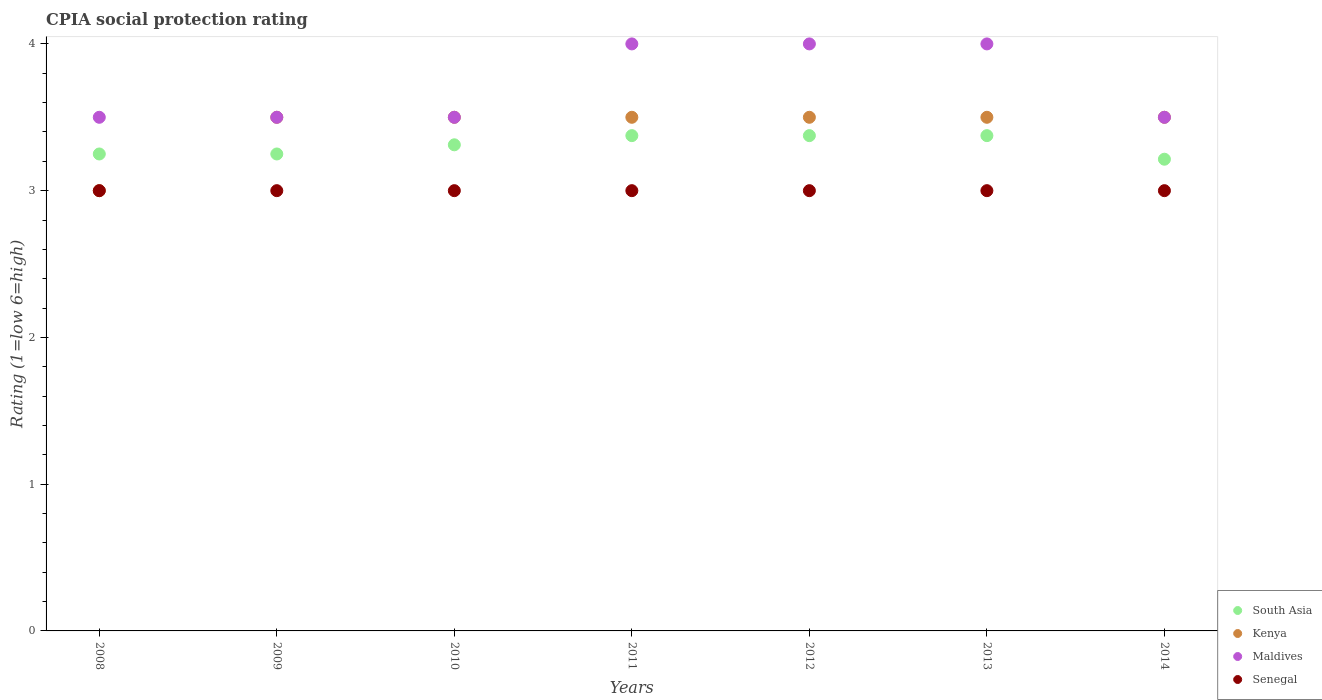How many different coloured dotlines are there?
Make the answer very short. 4. What is the CPIA rating in Maldives in 2013?
Give a very brief answer. 4. Across all years, what is the maximum CPIA rating in South Asia?
Provide a short and direct response. 3.38. In which year was the CPIA rating in Kenya maximum?
Give a very brief answer. 2009. What is the difference between the CPIA rating in Maldives in 2010 and that in 2012?
Your answer should be compact. -0.5. What is the difference between the CPIA rating in Senegal in 2009 and the CPIA rating in Maldives in 2010?
Ensure brevity in your answer.  -0.5. What is the average CPIA rating in South Asia per year?
Your response must be concise. 3.31. In the year 2013, what is the difference between the CPIA rating in Senegal and CPIA rating in South Asia?
Offer a very short reply. -0.38. In how many years, is the CPIA rating in South Asia greater than 2.4?
Give a very brief answer. 7. What is the difference between the highest and the second highest CPIA rating in Kenya?
Your response must be concise. 0. What is the difference between the highest and the lowest CPIA rating in Kenya?
Keep it short and to the point. 0.5. Is it the case that in every year, the sum of the CPIA rating in Kenya and CPIA rating in Senegal  is greater than the sum of CPIA rating in South Asia and CPIA rating in Maldives?
Your answer should be compact. No. Is it the case that in every year, the sum of the CPIA rating in Senegal and CPIA rating in Kenya  is greater than the CPIA rating in Maldives?
Your answer should be compact. Yes. Does the CPIA rating in Maldives monotonically increase over the years?
Your answer should be compact. No. Is the CPIA rating in Senegal strictly greater than the CPIA rating in South Asia over the years?
Your response must be concise. No. How many years are there in the graph?
Keep it short and to the point. 7. Are the values on the major ticks of Y-axis written in scientific E-notation?
Offer a terse response. No. Does the graph contain grids?
Keep it short and to the point. No. How many legend labels are there?
Ensure brevity in your answer.  4. How are the legend labels stacked?
Ensure brevity in your answer.  Vertical. What is the title of the graph?
Your answer should be compact. CPIA social protection rating. What is the label or title of the X-axis?
Your response must be concise. Years. What is the label or title of the Y-axis?
Your answer should be very brief. Rating (1=low 6=high). What is the Rating (1=low 6=high) in South Asia in 2008?
Ensure brevity in your answer.  3.25. What is the Rating (1=low 6=high) of Maldives in 2008?
Keep it short and to the point. 3.5. What is the Rating (1=low 6=high) of South Asia in 2009?
Offer a very short reply. 3.25. What is the Rating (1=low 6=high) of Maldives in 2009?
Offer a very short reply. 3.5. What is the Rating (1=low 6=high) in Senegal in 2009?
Your answer should be compact. 3. What is the Rating (1=low 6=high) of South Asia in 2010?
Give a very brief answer. 3.31. What is the Rating (1=low 6=high) of Kenya in 2010?
Your answer should be compact. 3.5. What is the Rating (1=low 6=high) in South Asia in 2011?
Offer a terse response. 3.38. What is the Rating (1=low 6=high) in Kenya in 2011?
Your response must be concise. 3.5. What is the Rating (1=low 6=high) in South Asia in 2012?
Make the answer very short. 3.38. What is the Rating (1=low 6=high) of Kenya in 2012?
Offer a terse response. 3.5. What is the Rating (1=low 6=high) of Maldives in 2012?
Offer a very short reply. 4. What is the Rating (1=low 6=high) in Senegal in 2012?
Give a very brief answer. 3. What is the Rating (1=low 6=high) in South Asia in 2013?
Provide a short and direct response. 3.38. What is the Rating (1=low 6=high) in Maldives in 2013?
Your response must be concise. 4. What is the Rating (1=low 6=high) of South Asia in 2014?
Your response must be concise. 3.21. What is the Rating (1=low 6=high) of Senegal in 2014?
Your answer should be very brief. 3. Across all years, what is the maximum Rating (1=low 6=high) of South Asia?
Your response must be concise. 3.38. Across all years, what is the minimum Rating (1=low 6=high) of South Asia?
Make the answer very short. 3.21. Across all years, what is the minimum Rating (1=low 6=high) in Senegal?
Your response must be concise. 3. What is the total Rating (1=low 6=high) in South Asia in the graph?
Provide a short and direct response. 23.15. What is the total Rating (1=low 6=high) in Kenya in the graph?
Give a very brief answer. 24. What is the total Rating (1=low 6=high) of Maldives in the graph?
Your response must be concise. 26. What is the difference between the Rating (1=low 6=high) of South Asia in 2008 and that in 2009?
Offer a terse response. 0. What is the difference between the Rating (1=low 6=high) of Kenya in 2008 and that in 2009?
Give a very brief answer. -0.5. What is the difference between the Rating (1=low 6=high) of Maldives in 2008 and that in 2009?
Your answer should be very brief. 0. What is the difference between the Rating (1=low 6=high) of South Asia in 2008 and that in 2010?
Your response must be concise. -0.06. What is the difference between the Rating (1=low 6=high) of Maldives in 2008 and that in 2010?
Offer a very short reply. 0. What is the difference between the Rating (1=low 6=high) of South Asia in 2008 and that in 2011?
Provide a succinct answer. -0.12. What is the difference between the Rating (1=low 6=high) in Kenya in 2008 and that in 2011?
Ensure brevity in your answer.  -0.5. What is the difference between the Rating (1=low 6=high) in Maldives in 2008 and that in 2011?
Your answer should be very brief. -0.5. What is the difference between the Rating (1=low 6=high) in Senegal in 2008 and that in 2011?
Ensure brevity in your answer.  0. What is the difference between the Rating (1=low 6=high) of South Asia in 2008 and that in 2012?
Your answer should be very brief. -0.12. What is the difference between the Rating (1=low 6=high) of South Asia in 2008 and that in 2013?
Keep it short and to the point. -0.12. What is the difference between the Rating (1=low 6=high) in Maldives in 2008 and that in 2013?
Your answer should be compact. -0.5. What is the difference between the Rating (1=low 6=high) in Senegal in 2008 and that in 2013?
Give a very brief answer. 0. What is the difference between the Rating (1=low 6=high) of South Asia in 2008 and that in 2014?
Make the answer very short. 0.04. What is the difference between the Rating (1=low 6=high) of Kenya in 2008 and that in 2014?
Your response must be concise. -0.5. What is the difference between the Rating (1=low 6=high) of Senegal in 2008 and that in 2014?
Your answer should be very brief. 0. What is the difference between the Rating (1=low 6=high) of South Asia in 2009 and that in 2010?
Your response must be concise. -0.06. What is the difference between the Rating (1=low 6=high) in Maldives in 2009 and that in 2010?
Offer a terse response. 0. What is the difference between the Rating (1=low 6=high) of South Asia in 2009 and that in 2011?
Ensure brevity in your answer.  -0.12. What is the difference between the Rating (1=low 6=high) of Senegal in 2009 and that in 2011?
Your answer should be very brief. 0. What is the difference between the Rating (1=low 6=high) of South Asia in 2009 and that in 2012?
Offer a terse response. -0.12. What is the difference between the Rating (1=low 6=high) in Kenya in 2009 and that in 2012?
Ensure brevity in your answer.  0. What is the difference between the Rating (1=low 6=high) in Senegal in 2009 and that in 2012?
Your answer should be very brief. 0. What is the difference between the Rating (1=low 6=high) in South Asia in 2009 and that in 2013?
Your response must be concise. -0.12. What is the difference between the Rating (1=low 6=high) in Kenya in 2009 and that in 2013?
Offer a very short reply. 0. What is the difference between the Rating (1=low 6=high) in Senegal in 2009 and that in 2013?
Your response must be concise. 0. What is the difference between the Rating (1=low 6=high) in South Asia in 2009 and that in 2014?
Make the answer very short. 0.04. What is the difference between the Rating (1=low 6=high) of Kenya in 2009 and that in 2014?
Your answer should be compact. 0. What is the difference between the Rating (1=low 6=high) of Maldives in 2009 and that in 2014?
Provide a short and direct response. 0. What is the difference between the Rating (1=low 6=high) in South Asia in 2010 and that in 2011?
Provide a succinct answer. -0.06. What is the difference between the Rating (1=low 6=high) of Maldives in 2010 and that in 2011?
Provide a succinct answer. -0.5. What is the difference between the Rating (1=low 6=high) in Senegal in 2010 and that in 2011?
Your answer should be very brief. 0. What is the difference between the Rating (1=low 6=high) in South Asia in 2010 and that in 2012?
Offer a terse response. -0.06. What is the difference between the Rating (1=low 6=high) of Senegal in 2010 and that in 2012?
Offer a very short reply. 0. What is the difference between the Rating (1=low 6=high) of South Asia in 2010 and that in 2013?
Your answer should be compact. -0.06. What is the difference between the Rating (1=low 6=high) of Senegal in 2010 and that in 2013?
Your answer should be compact. 0. What is the difference between the Rating (1=low 6=high) of South Asia in 2010 and that in 2014?
Give a very brief answer. 0.1. What is the difference between the Rating (1=low 6=high) in Maldives in 2011 and that in 2012?
Provide a short and direct response. 0. What is the difference between the Rating (1=low 6=high) of Senegal in 2011 and that in 2012?
Provide a short and direct response. 0. What is the difference between the Rating (1=low 6=high) in Maldives in 2011 and that in 2013?
Give a very brief answer. 0. What is the difference between the Rating (1=low 6=high) of South Asia in 2011 and that in 2014?
Give a very brief answer. 0.16. What is the difference between the Rating (1=low 6=high) in Maldives in 2011 and that in 2014?
Give a very brief answer. 0.5. What is the difference between the Rating (1=low 6=high) of Senegal in 2011 and that in 2014?
Give a very brief answer. 0. What is the difference between the Rating (1=low 6=high) in Kenya in 2012 and that in 2013?
Your response must be concise. 0. What is the difference between the Rating (1=low 6=high) of Maldives in 2012 and that in 2013?
Your answer should be very brief. 0. What is the difference between the Rating (1=low 6=high) of Senegal in 2012 and that in 2013?
Offer a very short reply. 0. What is the difference between the Rating (1=low 6=high) in South Asia in 2012 and that in 2014?
Provide a short and direct response. 0.16. What is the difference between the Rating (1=low 6=high) of Kenya in 2012 and that in 2014?
Give a very brief answer. 0. What is the difference between the Rating (1=low 6=high) of Senegal in 2012 and that in 2014?
Your answer should be compact. 0. What is the difference between the Rating (1=low 6=high) in South Asia in 2013 and that in 2014?
Your response must be concise. 0.16. What is the difference between the Rating (1=low 6=high) in Kenya in 2013 and that in 2014?
Ensure brevity in your answer.  0. What is the difference between the Rating (1=low 6=high) of Maldives in 2013 and that in 2014?
Offer a terse response. 0.5. What is the difference between the Rating (1=low 6=high) in Kenya in 2008 and the Rating (1=low 6=high) in Maldives in 2009?
Keep it short and to the point. -0.5. What is the difference between the Rating (1=low 6=high) of Kenya in 2008 and the Rating (1=low 6=high) of Senegal in 2009?
Make the answer very short. 0. What is the difference between the Rating (1=low 6=high) in South Asia in 2008 and the Rating (1=low 6=high) in Kenya in 2010?
Your answer should be compact. -0.25. What is the difference between the Rating (1=low 6=high) in South Asia in 2008 and the Rating (1=low 6=high) in Senegal in 2010?
Offer a very short reply. 0.25. What is the difference between the Rating (1=low 6=high) of South Asia in 2008 and the Rating (1=low 6=high) of Kenya in 2011?
Your answer should be very brief. -0.25. What is the difference between the Rating (1=low 6=high) in South Asia in 2008 and the Rating (1=low 6=high) in Maldives in 2011?
Your answer should be compact. -0.75. What is the difference between the Rating (1=low 6=high) of Kenya in 2008 and the Rating (1=low 6=high) of Maldives in 2011?
Your response must be concise. -1. What is the difference between the Rating (1=low 6=high) in Maldives in 2008 and the Rating (1=low 6=high) in Senegal in 2011?
Your answer should be compact. 0.5. What is the difference between the Rating (1=low 6=high) of South Asia in 2008 and the Rating (1=low 6=high) of Kenya in 2012?
Provide a succinct answer. -0.25. What is the difference between the Rating (1=low 6=high) of South Asia in 2008 and the Rating (1=low 6=high) of Maldives in 2012?
Offer a terse response. -0.75. What is the difference between the Rating (1=low 6=high) in Maldives in 2008 and the Rating (1=low 6=high) in Senegal in 2012?
Provide a short and direct response. 0.5. What is the difference between the Rating (1=low 6=high) of South Asia in 2008 and the Rating (1=low 6=high) of Kenya in 2013?
Your answer should be very brief. -0.25. What is the difference between the Rating (1=low 6=high) in South Asia in 2008 and the Rating (1=low 6=high) in Maldives in 2013?
Ensure brevity in your answer.  -0.75. What is the difference between the Rating (1=low 6=high) of South Asia in 2008 and the Rating (1=low 6=high) of Senegal in 2013?
Make the answer very short. 0.25. What is the difference between the Rating (1=low 6=high) in Kenya in 2008 and the Rating (1=low 6=high) in Senegal in 2013?
Your answer should be compact. 0. What is the difference between the Rating (1=low 6=high) of Kenya in 2008 and the Rating (1=low 6=high) of Maldives in 2014?
Your response must be concise. -0.5. What is the difference between the Rating (1=low 6=high) in Maldives in 2008 and the Rating (1=low 6=high) in Senegal in 2014?
Ensure brevity in your answer.  0.5. What is the difference between the Rating (1=low 6=high) of Kenya in 2009 and the Rating (1=low 6=high) of Maldives in 2010?
Offer a terse response. 0. What is the difference between the Rating (1=low 6=high) of Kenya in 2009 and the Rating (1=low 6=high) of Senegal in 2010?
Give a very brief answer. 0.5. What is the difference between the Rating (1=low 6=high) in Maldives in 2009 and the Rating (1=low 6=high) in Senegal in 2010?
Give a very brief answer. 0.5. What is the difference between the Rating (1=low 6=high) in South Asia in 2009 and the Rating (1=low 6=high) in Kenya in 2011?
Your response must be concise. -0.25. What is the difference between the Rating (1=low 6=high) of South Asia in 2009 and the Rating (1=low 6=high) of Maldives in 2011?
Ensure brevity in your answer.  -0.75. What is the difference between the Rating (1=low 6=high) of South Asia in 2009 and the Rating (1=low 6=high) of Senegal in 2011?
Your answer should be compact. 0.25. What is the difference between the Rating (1=low 6=high) of Kenya in 2009 and the Rating (1=low 6=high) of Maldives in 2011?
Provide a succinct answer. -0.5. What is the difference between the Rating (1=low 6=high) of Maldives in 2009 and the Rating (1=low 6=high) of Senegal in 2011?
Ensure brevity in your answer.  0.5. What is the difference between the Rating (1=low 6=high) of South Asia in 2009 and the Rating (1=low 6=high) of Kenya in 2012?
Keep it short and to the point. -0.25. What is the difference between the Rating (1=low 6=high) in South Asia in 2009 and the Rating (1=low 6=high) in Maldives in 2012?
Provide a short and direct response. -0.75. What is the difference between the Rating (1=low 6=high) of Kenya in 2009 and the Rating (1=low 6=high) of Maldives in 2012?
Offer a very short reply. -0.5. What is the difference between the Rating (1=low 6=high) of Kenya in 2009 and the Rating (1=low 6=high) of Senegal in 2012?
Ensure brevity in your answer.  0.5. What is the difference between the Rating (1=low 6=high) of South Asia in 2009 and the Rating (1=low 6=high) of Maldives in 2013?
Make the answer very short. -0.75. What is the difference between the Rating (1=low 6=high) in South Asia in 2009 and the Rating (1=low 6=high) in Senegal in 2013?
Keep it short and to the point. 0.25. What is the difference between the Rating (1=low 6=high) in Kenya in 2009 and the Rating (1=low 6=high) in Maldives in 2013?
Provide a succinct answer. -0.5. What is the difference between the Rating (1=low 6=high) of South Asia in 2009 and the Rating (1=low 6=high) of Maldives in 2014?
Offer a terse response. -0.25. What is the difference between the Rating (1=low 6=high) in South Asia in 2009 and the Rating (1=low 6=high) in Senegal in 2014?
Give a very brief answer. 0.25. What is the difference between the Rating (1=low 6=high) in Kenya in 2009 and the Rating (1=low 6=high) in Maldives in 2014?
Give a very brief answer. 0. What is the difference between the Rating (1=low 6=high) in Kenya in 2009 and the Rating (1=low 6=high) in Senegal in 2014?
Ensure brevity in your answer.  0.5. What is the difference between the Rating (1=low 6=high) in South Asia in 2010 and the Rating (1=low 6=high) in Kenya in 2011?
Give a very brief answer. -0.19. What is the difference between the Rating (1=low 6=high) in South Asia in 2010 and the Rating (1=low 6=high) in Maldives in 2011?
Make the answer very short. -0.69. What is the difference between the Rating (1=low 6=high) of South Asia in 2010 and the Rating (1=low 6=high) of Senegal in 2011?
Give a very brief answer. 0.31. What is the difference between the Rating (1=low 6=high) of South Asia in 2010 and the Rating (1=low 6=high) of Kenya in 2012?
Make the answer very short. -0.19. What is the difference between the Rating (1=low 6=high) in South Asia in 2010 and the Rating (1=low 6=high) in Maldives in 2012?
Ensure brevity in your answer.  -0.69. What is the difference between the Rating (1=low 6=high) of South Asia in 2010 and the Rating (1=low 6=high) of Senegal in 2012?
Make the answer very short. 0.31. What is the difference between the Rating (1=low 6=high) in South Asia in 2010 and the Rating (1=low 6=high) in Kenya in 2013?
Make the answer very short. -0.19. What is the difference between the Rating (1=low 6=high) in South Asia in 2010 and the Rating (1=low 6=high) in Maldives in 2013?
Make the answer very short. -0.69. What is the difference between the Rating (1=low 6=high) of South Asia in 2010 and the Rating (1=low 6=high) of Senegal in 2013?
Provide a succinct answer. 0.31. What is the difference between the Rating (1=low 6=high) of Kenya in 2010 and the Rating (1=low 6=high) of Maldives in 2013?
Provide a short and direct response. -0.5. What is the difference between the Rating (1=low 6=high) in South Asia in 2010 and the Rating (1=low 6=high) in Kenya in 2014?
Provide a succinct answer. -0.19. What is the difference between the Rating (1=low 6=high) in South Asia in 2010 and the Rating (1=low 6=high) in Maldives in 2014?
Your response must be concise. -0.19. What is the difference between the Rating (1=low 6=high) of South Asia in 2010 and the Rating (1=low 6=high) of Senegal in 2014?
Make the answer very short. 0.31. What is the difference between the Rating (1=low 6=high) in Kenya in 2010 and the Rating (1=low 6=high) in Senegal in 2014?
Provide a short and direct response. 0.5. What is the difference between the Rating (1=low 6=high) of South Asia in 2011 and the Rating (1=low 6=high) of Kenya in 2012?
Keep it short and to the point. -0.12. What is the difference between the Rating (1=low 6=high) of South Asia in 2011 and the Rating (1=low 6=high) of Maldives in 2012?
Keep it short and to the point. -0.62. What is the difference between the Rating (1=low 6=high) of Kenya in 2011 and the Rating (1=low 6=high) of Maldives in 2012?
Keep it short and to the point. -0.5. What is the difference between the Rating (1=low 6=high) in Kenya in 2011 and the Rating (1=low 6=high) in Senegal in 2012?
Provide a succinct answer. 0.5. What is the difference between the Rating (1=low 6=high) in Maldives in 2011 and the Rating (1=low 6=high) in Senegal in 2012?
Make the answer very short. 1. What is the difference between the Rating (1=low 6=high) of South Asia in 2011 and the Rating (1=low 6=high) of Kenya in 2013?
Ensure brevity in your answer.  -0.12. What is the difference between the Rating (1=low 6=high) of South Asia in 2011 and the Rating (1=low 6=high) of Maldives in 2013?
Offer a terse response. -0.62. What is the difference between the Rating (1=low 6=high) in South Asia in 2011 and the Rating (1=low 6=high) in Senegal in 2013?
Your response must be concise. 0.38. What is the difference between the Rating (1=low 6=high) of Kenya in 2011 and the Rating (1=low 6=high) of Maldives in 2013?
Offer a terse response. -0.5. What is the difference between the Rating (1=low 6=high) of Maldives in 2011 and the Rating (1=low 6=high) of Senegal in 2013?
Make the answer very short. 1. What is the difference between the Rating (1=low 6=high) of South Asia in 2011 and the Rating (1=low 6=high) of Kenya in 2014?
Keep it short and to the point. -0.12. What is the difference between the Rating (1=low 6=high) of South Asia in 2011 and the Rating (1=low 6=high) of Maldives in 2014?
Ensure brevity in your answer.  -0.12. What is the difference between the Rating (1=low 6=high) of South Asia in 2012 and the Rating (1=low 6=high) of Kenya in 2013?
Offer a very short reply. -0.12. What is the difference between the Rating (1=low 6=high) in South Asia in 2012 and the Rating (1=low 6=high) in Maldives in 2013?
Ensure brevity in your answer.  -0.62. What is the difference between the Rating (1=low 6=high) of Kenya in 2012 and the Rating (1=low 6=high) of Maldives in 2013?
Provide a short and direct response. -0.5. What is the difference between the Rating (1=low 6=high) in South Asia in 2012 and the Rating (1=low 6=high) in Kenya in 2014?
Ensure brevity in your answer.  -0.12. What is the difference between the Rating (1=low 6=high) of South Asia in 2012 and the Rating (1=low 6=high) of Maldives in 2014?
Ensure brevity in your answer.  -0.12. What is the difference between the Rating (1=low 6=high) in South Asia in 2012 and the Rating (1=low 6=high) in Senegal in 2014?
Your answer should be very brief. 0.38. What is the difference between the Rating (1=low 6=high) in South Asia in 2013 and the Rating (1=low 6=high) in Kenya in 2014?
Your answer should be compact. -0.12. What is the difference between the Rating (1=low 6=high) of South Asia in 2013 and the Rating (1=low 6=high) of Maldives in 2014?
Your response must be concise. -0.12. What is the difference between the Rating (1=low 6=high) of South Asia in 2013 and the Rating (1=low 6=high) of Senegal in 2014?
Offer a very short reply. 0.38. What is the difference between the Rating (1=low 6=high) in Kenya in 2013 and the Rating (1=low 6=high) in Maldives in 2014?
Provide a short and direct response. 0. What is the average Rating (1=low 6=high) of South Asia per year?
Your response must be concise. 3.31. What is the average Rating (1=low 6=high) of Kenya per year?
Your answer should be very brief. 3.43. What is the average Rating (1=low 6=high) of Maldives per year?
Provide a short and direct response. 3.71. In the year 2008, what is the difference between the Rating (1=low 6=high) in South Asia and Rating (1=low 6=high) in Maldives?
Your answer should be compact. -0.25. In the year 2008, what is the difference between the Rating (1=low 6=high) of Kenya and Rating (1=low 6=high) of Maldives?
Provide a succinct answer. -0.5. In the year 2008, what is the difference between the Rating (1=low 6=high) in Maldives and Rating (1=low 6=high) in Senegal?
Ensure brevity in your answer.  0.5. In the year 2009, what is the difference between the Rating (1=low 6=high) of South Asia and Rating (1=low 6=high) of Kenya?
Your answer should be very brief. -0.25. In the year 2009, what is the difference between the Rating (1=low 6=high) in South Asia and Rating (1=low 6=high) in Senegal?
Offer a very short reply. 0.25. In the year 2009, what is the difference between the Rating (1=low 6=high) in Maldives and Rating (1=low 6=high) in Senegal?
Keep it short and to the point. 0.5. In the year 2010, what is the difference between the Rating (1=low 6=high) of South Asia and Rating (1=low 6=high) of Kenya?
Keep it short and to the point. -0.19. In the year 2010, what is the difference between the Rating (1=low 6=high) of South Asia and Rating (1=low 6=high) of Maldives?
Ensure brevity in your answer.  -0.19. In the year 2010, what is the difference between the Rating (1=low 6=high) of South Asia and Rating (1=low 6=high) of Senegal?
Your response must be concise. 0.31. In the year 2010, what is the difference between the Rating (1=low 6=high) in Kenya and Rating (1=low 6=high) in Maldives?
Your answer should be compact. 0. In the year 2010, what is the difference between the Rating (1=low 6=high) of Kenya and Rating (1=low 6=high) of Senegal?
Your response must be concise. 0.5. In the year 2010, what is the difference between the Rating (1=low 6=high) in Maldives and Rating (1=low 6=high) in Senegal?
Your answer should be compact. 0.5. In the year 2011, what is the difference between the Rating (1=low 6=high) of South Asia and Rating (1=low 6=high) of Kenya?
Provide a succinct answer. -0.12. In the year 2011, what is the difference between the Rating (1=low 6=high) of South Asia and Rating (1=low 6=high) of Maldives?
Offer a terse response. -0.62. In the year 2011, what is the difference between the Rating (1=low 6=high) of South Asia and Rating (1=low 6=high) of Senegal?
Your answer should be very brief. 0.38. In the year 2011, what is the difference between the Rating (1=low 6=high) of Kenya and Rating (1=low 6=high) of Senegal?
Ensure brevity in your answer.  0.5. In the year 2012, what is the difference between the Rating (1=low 6=high) of South Asia and Rating (1=low 6=high) of Kenya?
Give a very brief answer. -0.12. In the year 2012, what is the difference between the Rating (1=low 6=high) in South Asia and Rating (1=low 6=high) in Maldives?
Provide a short and direct response. -0.62. In the year 2012, what is the difference between the Rating (1=low 6=high) of Kenya and Rating (1=low 6=high) of Senegal?
Ensure brevity in your answer.  0.5. In the year 2013, what is the difference between the Rating (1=low 6=high) of South Asia and Rating (1=low 6=high) of Kenya?
Your answer should be compact. -0.12. In the year 2013, what is the difference between the Rating (1=low 6=high) in South Asia and Rating (1=low 6=high) in Maldives?
Your answer should be very brief. -0.62. In the year 2013, what is the difference between the Rating (1=low 6=high) in Kenya and Rating (1=low 6=high) in Senegal?
Make the answer very short. 0.5. In the year 2013, what is the difference between the Rating (1=low 6=high) of Maldives and Rating (1=low 6=high) of Senegal?
Provide a succinct answer. 1. In the year 2014, what is the difference between the Rating (1=low 6=high) of South Asia and Rating (1=low 6=high) of Kenya?
Ensure brevity in your answer.  -0.29. In the year 2014, what is the difference between the Rating (1=low 6=high) in South Asia and Rating (1=low 6=high) in Maldives?
Ensure brevity in your answer.  -0.29. In the year 2014, what is the difference between the Rating (1=low 6=high) of South Asia and Rating (1=low 6=high) of Senegal?
Provide a succinct answer. 0.21. In the year 2014, what is the difference between the Rating (1=low 6=high) in Kenya and Rating (1=low 6=high) in Maldives?
Give a very brief answer. 0. In the year 2014, what is the difference between the Rating (1=low 6=high) in Maldives and Rating (1=low 6=high) in Senegal?
Provide a short and direct response. 0.5. What is the ratio of the Rating (1=low 6=high) in South Asia in 2008 to that in 2009?
Your answer should be very brief. 1. What is the ratio of the Rating (1=low 6=high) of Kenya in 2008 to that in 2009?
Ensure brevity in your answer.  0.86. What is the ratio of the Rating (1=low 6=high) in South Asia in 2008 to that in 2010?
Offer a very short reply. 0.98. What is the ratio of the Rating (1=low 6=high) in Maldives in 2008 to that in 2010?
Give a very brief answer. 1. What is the ratio of the Rating (1=low 6=high) in Senegal in 2008 to that in 2010?
Provide a short and direct response. 1. What is the ratio of the Rating (1=low 6=high) of South Asia in 2008 to that in 2011?
Provide a succinct answer. 0.96. What is the ratio of the Rating (1=low 6=high) in Kenya in 2008 to that in 2011?
Your response must be concise. 0.86. What is the ratio of the Rating (1=low 6=high) in Maldives in 2008 to that in 2011?
Offer a very short reply. 0.88. What is the ratio of the Rating (1=low 6=high) of Senegal in 2008 to that in 2011?
Ensure brevity in your answer.  1. What is the ratio of the Rating (1=low 6=high) in Maldives in 2008 to that in 2012?
Your response must be concise. 0.88. What is the ratio of the Rating (1=low 6=high) in Senegal in 2008 to that in 2012?
Provide a succinct answer. 1. What is the ratio of the Rating (1=low 6=high) in Senegal in 2008 to that in 2013?
Make the answer very short. 1. What is the ratio of the Rating (1=low 6=high) in South Asia in 2008 to that in 2014?
Keep it short and to the point. 1.01. What is the ratio of the Rating (1=low 6=high) of Maldives in 2008 to that in 2014?
Ensure brevity in your answer.  1. What is the ratio of the Rating (1=low 6=high) in Senegal in 2008 to that in 2014?
Ensure brevity in your answer.  1. What is the ratio of the Rating (1=low 6=high) in South Asia in 2009 to that in 2010?
Provide a succinct answer. 0.98. What is the ratio of the Rating (1=low 6=high) in Senegal in 2009 to that in 2010?
Provide a short and direct response. 1. What is the ratio of the Rating (1=low 6=high) of South Asia in 2009 to that in 2011?
Your answer should be compact. 0.96. What is the ratio of the Rating (1=low 6=high) of Kenya in 2009 to that in 2011?
Your response must be concise. 1. What is the ratio of the Rating (1=low 6=high) of Maldives in 2009 to that in 2011?
Your response must be concise. 0.88. What is the ratio of the Rating (1=low 6=high) of Senegal in 2009 to that in 2011?
Provide a short and direct response. 1. What is the ratio of the Rating (1=low 6=high) in South Asia in 2009 to that in 2012?
Ensure brevity in your answer.  0.96. What is the ratio of the Rating (1=low 6=high) in Kenya in 2009 to that in 2012?
Offer a very short reply. 1. What is the ratio of the Rating (1=low 6=high) in Senegal in 2009 to that in 2012?
Provide a short and direct response. 1. What is the ratio of the Rating (1=low 6=high) in Kenya in 2009 to that in 2013?
Give a very brief answer. 1. What is the ratio of the Rating (1=low 6=high) in Senegal in 2009 to that in 2013?
Your response must be concise. 1. What is the ratio of the Rating (1=low 6=high) of South Asia in 2009 to that in 2014?
Provide a short and direct response. 1.01. What is the ratio of the Rating (1=low 6=high) of Maldives in 2009 to that in 2014?
Ensure brevity in your answer.  1. What is the ratio of the Rating (1=low 6=high) in Senegal in 2009 to that in 2014?
Ensure brevity in your answer.  1. What is the ratio of the Rating (1=low 6=high) in South Asia in 2010 to that in 2011?
Offer a very short reply. 0.98. What is the ratio of the Rating (1=low 6=high) of Kenya in 2010 to that in 2011?
Ensure brevity in your answer.  1. What is the ratio of the Rating (1=low 6=high) of Maldives in 2010 to that in 2011?
Your answer should be very brief. 0.88. What is the ratio of the Rating (1=low 6=high) of South Asia in 2010 to that in 2012?
Make the answer very short. 0.98. What is the ratio of the Rating (1=low 6=high) in Kenya in 2010 to that in 2012?
Make the answer very short. 1. What is the ratio of the Rating (1=low 6=high) of Maldives in 2010 to that in 2012?
Offer a very short reply. 0.88. What is the ratio of the Rating (1=low 6=high) in Senegal in 2010 to that in 2012?
Provide a succinct answer. 1. What is the ratio of the Rating (1=low 6=high) of South Asia in 2010 to that in 2013?
Provide a succinct answer. 0.98. What is the ratio of the Rating (1=low 6=high) of Maldives in 2010 to that in 2013?
Ensure brevity in your answer.  0.88. What is the ratio of the Rating (1=low 6=high) of South Asia in 2010 to that in 2014?
Your response must be concise. 1.03. What is the ratio of the Rating (1=low 6=high) of Kenya in 2010 to that in 2014?
Your answer should be compact. 1. What is the ratio of the Rating (1=low 6=high) of Kenya in 2011 to that in 2012?
Keep it short and to the point. 1. What is the ratio of the Rating (1=low 6=high) of Senegal in 2011 to that in 2012?
Provide a short and direct response. 1. What is the ratio of the Rating (1=low 6=high) of South Asia in 2011 to that in 2013?
Keep it short and to the point. 1. What is the ratio of the Rating (1=low 6=high) of Kenya in 2011 to that in 2013?
Your answer should be very brief. 1. What is the ratio of the Rating (1=low 6=high) of Maldives in 2011 to that in 2013?
Your answer should be compact. 1. What is the ratio of the Rating (1=low 6=high) of Senegal in 2011 to that in 2013?
Provide a succinct answer. 1. What is the ratio of the Rating (1=low 6=high) in South Asia in 2011 to that in 2014?
Ensure brevity in your answer.  1.05. What is the ratio of the Rating (1=low 6=high) of Kenya in 2011 to that in 2014?
Your response must be concise. 1. What is the ratio of the Rating (1=low 6=high) of Maldives in 2011 to that in 2014?
Provide a short and direct response. 1.14. What is the ratio of the Rating (1=low 6=high) in Senegal in 2012 to that in 2013?
Provide a short and direct response. 1. What is the ratio of the Rating (1=low 6=high) of Kenya in 2012 to that in 2014?
Offer a terse response. 1. What is the ratio of the Rating (1=low 6=high) of Maldives in 2012 to that in 2014?
Your answer should be very brief. 1.14. What is the ratio of the Rating (1=low 6=high) in South Asia in 2013 to that in 2014?
Your answer should be compact. 1.05. What is the ratio of the Rating (1=low 6=high) of Kenya in 2013 to that in 2014?
Make the answer very short. 1. What is the difference between the highest and the second highest Rating (1=low 6=high) in Kenya?
Your response must be concise. 0. What is the difference between the highest and the second highest Rating (1=low 6=high) of Maldives?
Give a very brief answer. 0. What is the difference between the highest and the lowest Rating (1=low 6=high) in South Asia?
Keep it short and to the point. 0.16. What is the difference between the highest and the lowest Rating (1=low 6=high) in Senegal?
Provide a succinct answer. 0. 